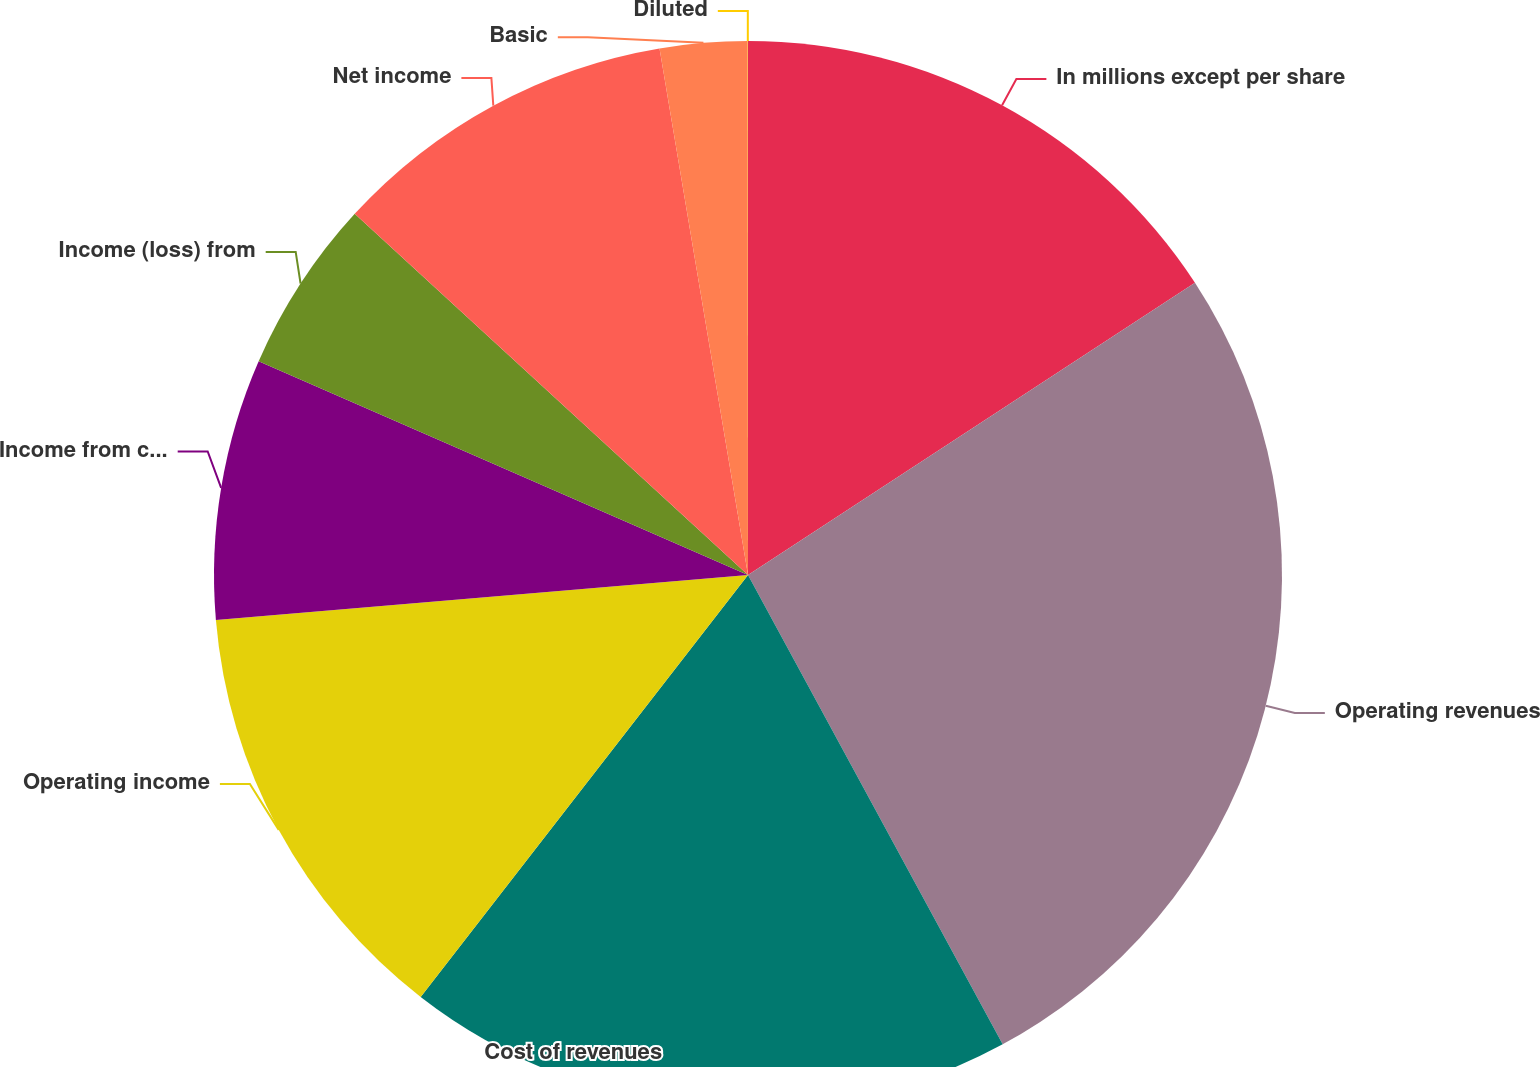Convert chart. <chart><loc_0><loc_0><loc_500><loc_500><pie_chart><fcel>In millions except per share<fcel>Operating revenues<fcel>Cost of revenues<fcel>Operating income<fcel>Income from continuing<fcel>Income (loss) from<fcel>Net income<fcel>Basic<fcel>Diluted<nl><fcel>15.79%<fcel>26.31%<fcel>18.42%<fcel>13.16%<fcel>7.9%<fcel>5.27%<fcel>10.53%<fcel>2.64%<fcel>0.01%<nl></chart> 